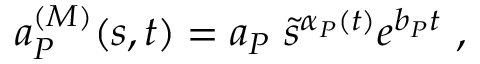Convert formula to latex. <formula><loc_0><loc_0><loc_500><loc_500>a _ { P } ^ { ( M ) } ( s , t ) = a _ { P } \ \tilde { s } ^ { \alpha _ { P } ( t ) } e ^ { b _ { P } t } \ ,</formula> 